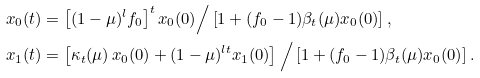<formula> <loc_0><loc_0><loc_500><loc_500>x _ { 0 } ( t ) & = \left [ ( 1 - \mu ) ^ { l } f _ { 0 } \right ] ^ { t } x _ { 0 } ( 0 ) \Big / \left [ 1 + ( f _ { 0 } - 1 ) \beta _ { t } ( \mu ) x _ { 0 } ( 0 ) \right ] , \\ x _ { 1 } ( t ) & = \left [ \kappa _ { t } ( \mu ) \, x _ { 0 } ( 0 ) + ( 1 - \mu ) ^ { l t } x _ { 1 } ( 0 ) \right ] \Big / \left [ 1 + ( f _ { 0 } - 1 ) \beta _ { t } ( \mu ) x _ { 0 } ( 0 ) \right ] .</formula> 